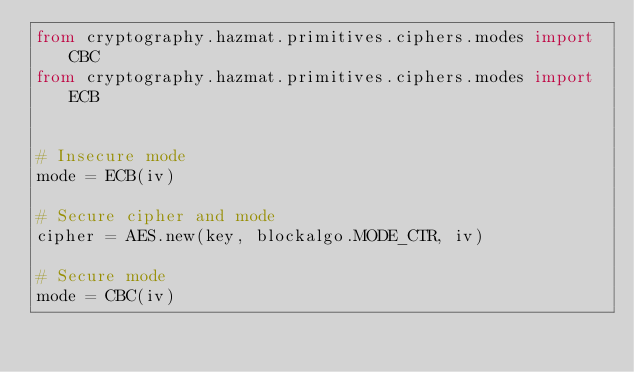<code> <loc_0><loc_0><loc_500><loc_500><_Python_>from cryptography.hazmat.primitives.ciphers.modes import CBC
from cryptography.hazmat.primitives.ciphers.modes import ECB


# Insecure mode
mode = ECB(iv)

# Secure cipher and mode
cipher = AES.new(key, blockalgo.MODE_CTR, iv)

# Secure mode
mode = CBC(iv)
</code> 